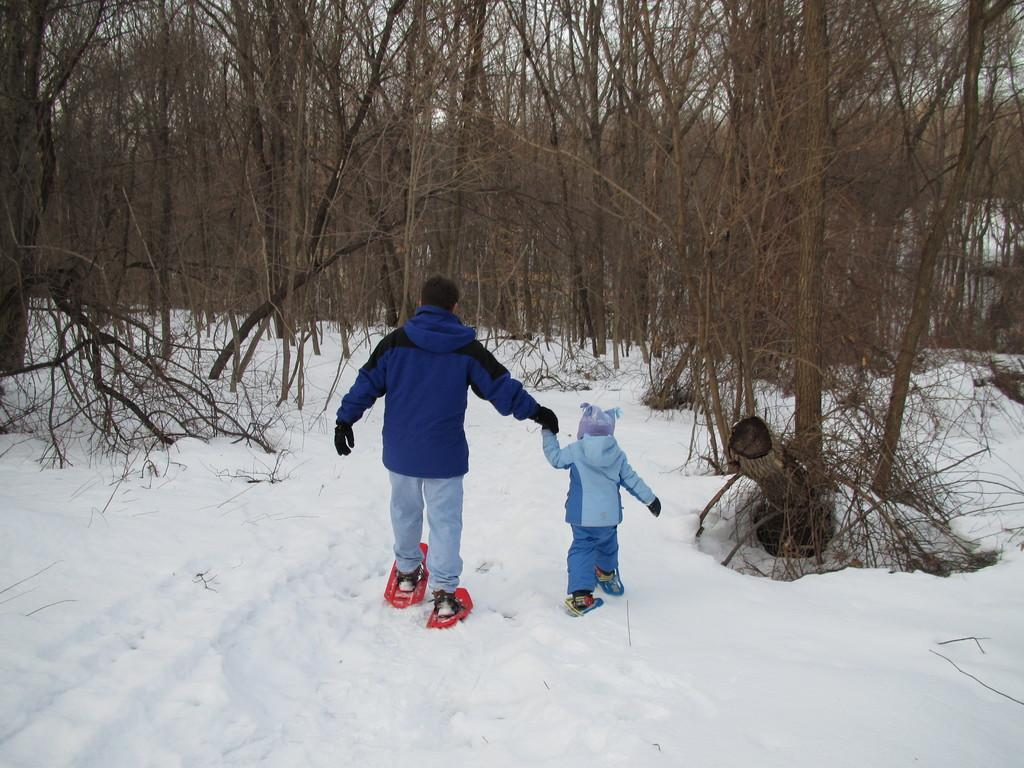How many people are in the image? There are two persons in the image. What are the persons doing in the image? The persons are standing on skiboards. What type of environment is depicted in the image? There are trees and snow in the image, suggesting a wintery or mountainous setting. What is visible in the background of the image? The sky is visible in the background of the image. What type of skin condition can be seen on the persons in the image? There is no indication of any skin condition on the persons in the image. Can you tell me how many bags of rice are visible in the image? There is no rice present in the image. 